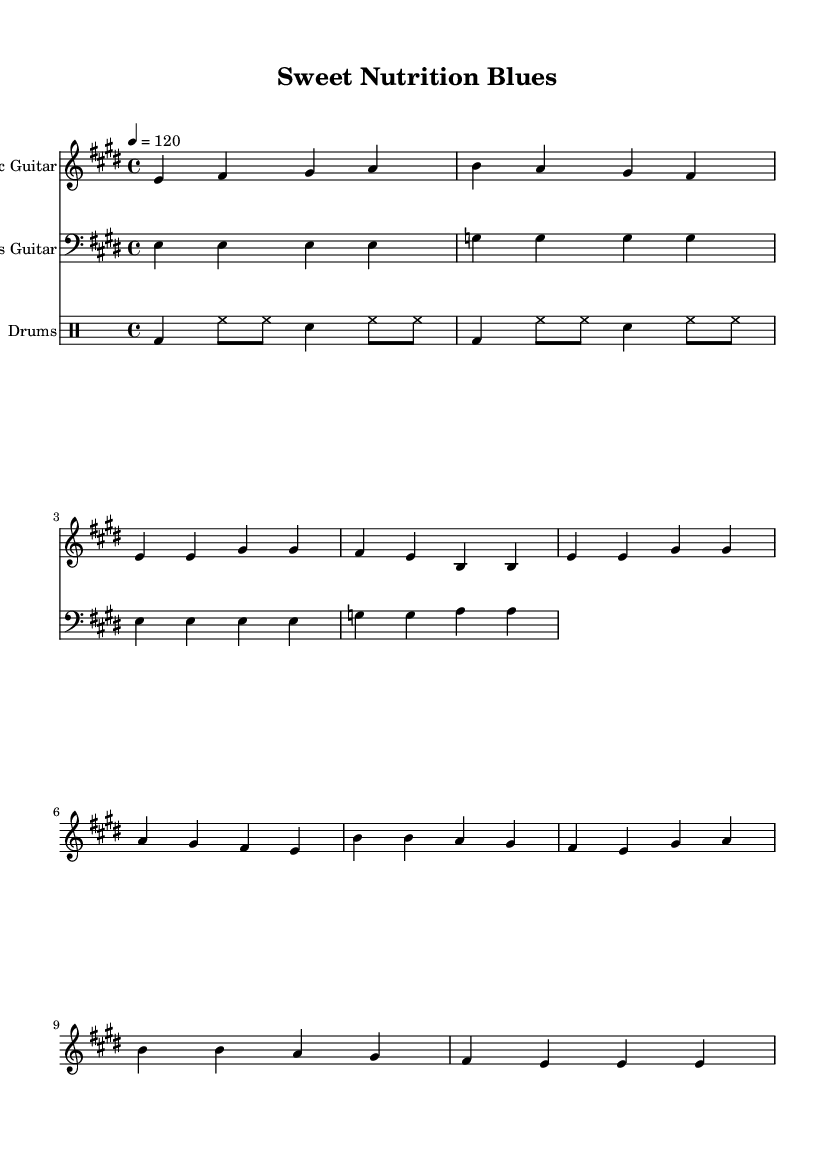What is the key signature of this music? The key signature is E major, which has four sharps (F#, C#, G#, D#). We determine this by looking at the key indication at the beginning of the score, which shows that the music is in E major.
Answer: E major What is the time signature of this music? The time signature is 4/4, indicated in the score at the beginning. This means there are four beats in a measure, and the quarter note gets one beat.
Answer: 4/4 What is the tempo of this piece? The tempo marking indicates that the piece should be played at 120 beats per minute (BPM). This is specified at the beginning of the score, showing the intended speed of the music.
Answer: 120 How many measures are in the chorus section? The chorus section includes 8 measures as evidenced by counting the measures from the start of the chorus to the end. Each group of beats separated by vertical lines represents a measure.
Answer: 8 What instrument has a bass clef in the score? The bass guitar part is written with a bass clef, which is used for lower-pitched instruments. It is found on the corresponding staff indicating that it plays in a lower range.
Answer: Bass Guitar What type of musical style does this piece exemplify? The piece exemplifies classic rock, which can be deduced from the instrumentation (electric guitar, bass, and drums) and the lyrical themes focusing on food and drink metaphors, characteristic of rock music.
Answer: Classic Rock 